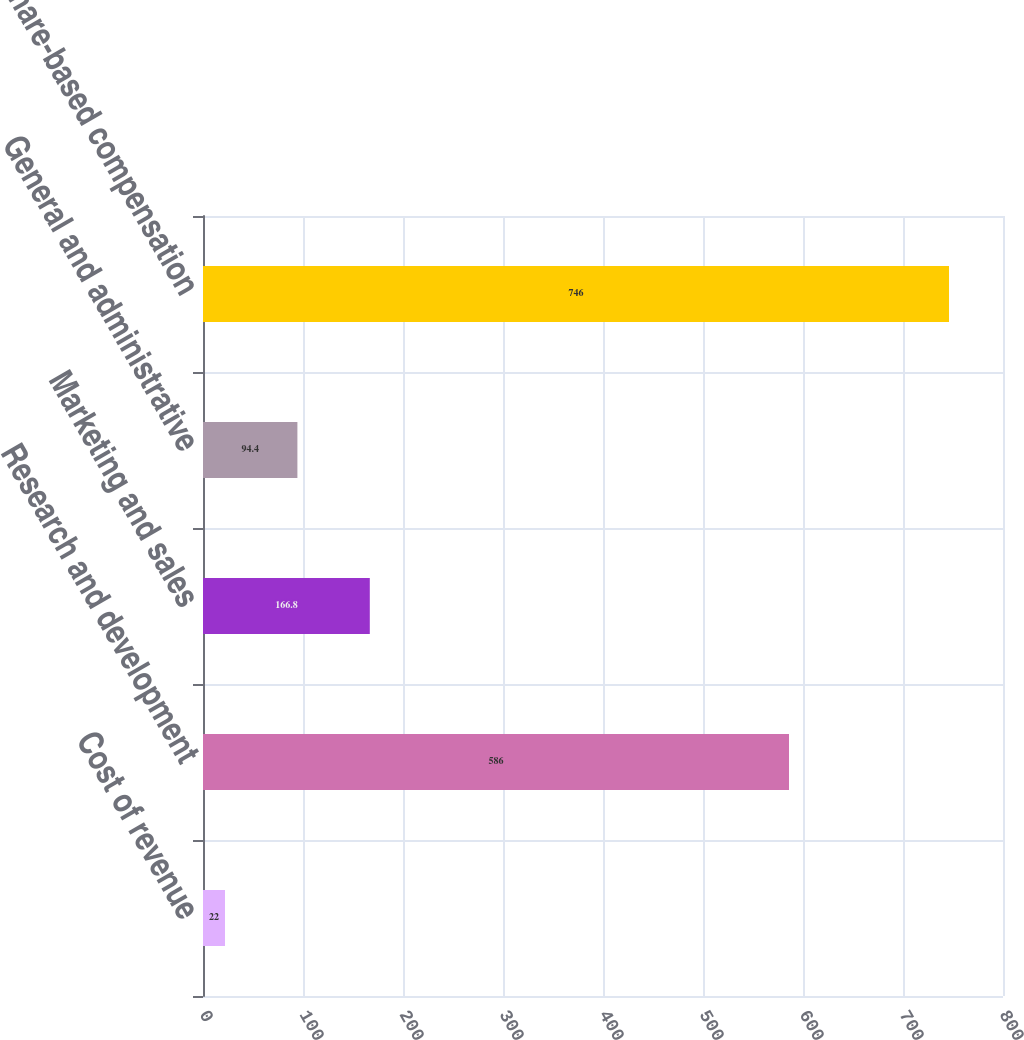Convert chart. <chart><loc_0><loc_0><loc_500><loc_500><bar_chart><fcel>Cost of revenue<fcel>Research and development<fcel>Marketing and sales<fcel>General and administrative<fcel>Total share-based compensation<nl><fcel>22<fcel>586<fcel>166.8<fcel>94.4<fcel>746<nl></chart> 